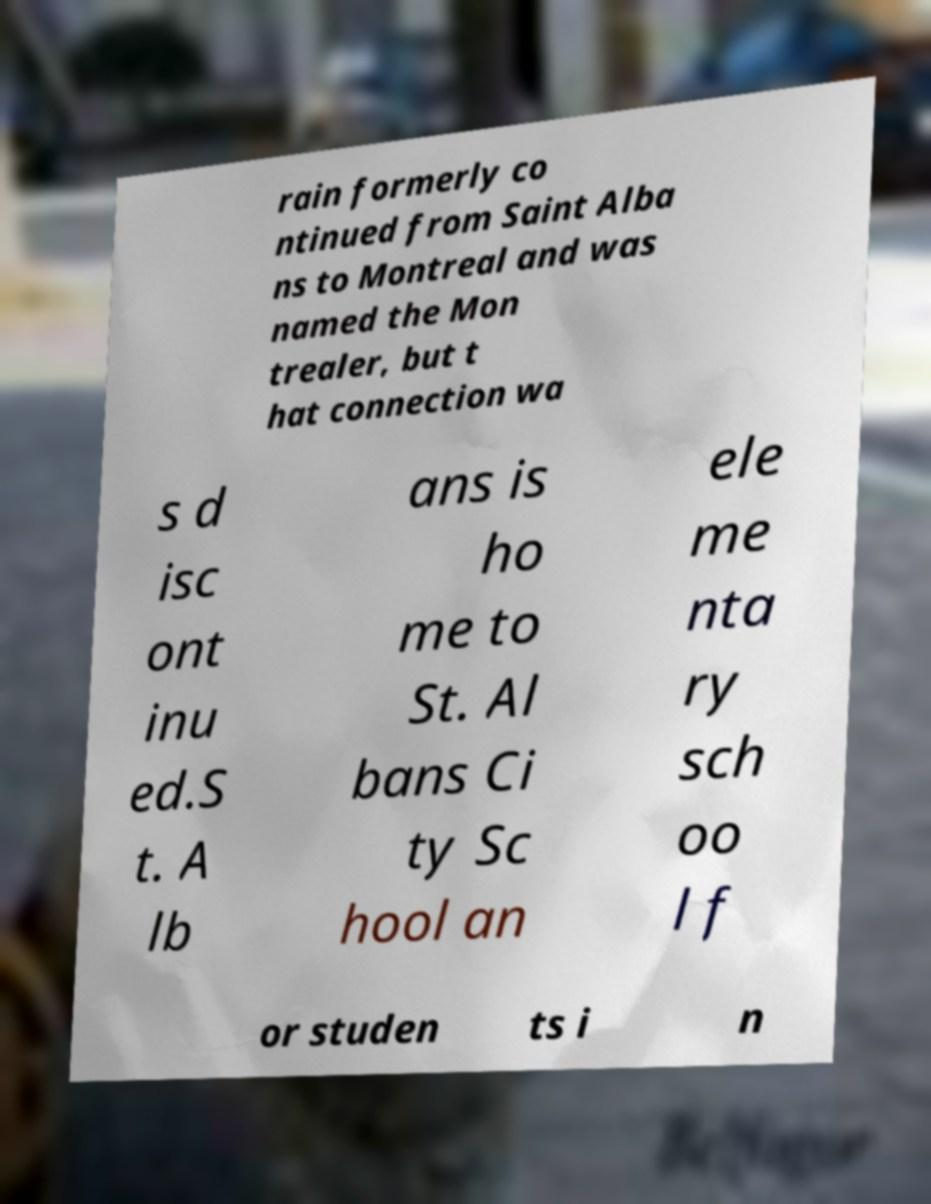Please read and relay the text visible in this image. What does it say? rain formerly co ntinued from Saint Alba ns to Montreal and was named the Mon trealer, but t hat connection wa s d isc ont inu ed.S t. A lb ans is ho me to St. Al bans Ci ty Sc hool an ele me nta ry sch oo l f or studen ts i n 